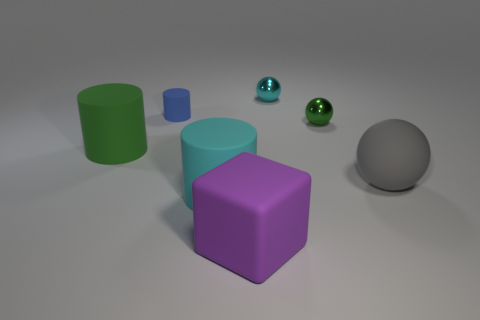Do the large cylinder on the right side of the blue rubber thing and the large thing that is on the right side of the small cyan metallic sphere have the same material?
Give a very brief answer. Yes. What number of things are tiny green shiny balls or balls behind the small green metal sphere?
Keep it short and to the point. 2. Is there anything else that has the same material as the small green object?
Your response must be concise. Yes. What is the cyan cylinder made of?
Provide a short and direct response. Rubber. Do the big cube and the cyan cylinder have the same material?
Make the answer very short. Yes. What number of metal objects are either green cylinders or large gray objects?
Your answer should be compact. 0. There is a rubber object behind the large green rubber thing; what shape is it?
Keep it short and to the point. Cylinder. What is the size of the ball that is made of the same material as the big purple cube?
Offer a very short reply. Large. There is a thing that is both right of the tiny rubber thing and behind the tiny green metallic sphere; what shape is it?
Provide a short and direct response. Sphere. Does the big rubber thing that is behind the gray object have the same color as the small rubber object?
Keep it short and to the point. No. 